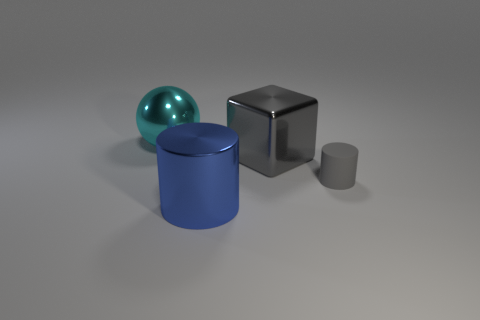What is the shape of the metal thing that is in front of the large gray object that is behind the shiny object that is in front of the matte thing?
Provide a short and direct response. Cylinder. Does the big thing in front of the shiny block have the same material as the gray thing that is in front of the metallic cube?
Provide a succinct answer. No. What is the big sphere made of?
Offer a terse response. Metal. What number of other gray matte objects are the same shape as the rubber object?
Your answer should be very brief. 0. What material is the object that is the same color as the large metallic cube?
Provide a short and direct response. Rubber. Is there any other thing that has the same shape as the cyan metallic object?
Your answer should be very brief. No. What is the color of the cylinder that is on the left side of the cylinder that is to the right of the large object in front of the metallic block?
Provide a short and direct response. Blue. How many small objects are either blue metallic spheres or blue shiny things?
Offer a terse response. 0. Are there an equal number of gray cylinders on the left side of the large cyan sphere and blue rubber cubes?
Your answer should be very brief. Yes. Are there any metal things on the right side of the big ball?
Offer a terse response. Yes. 